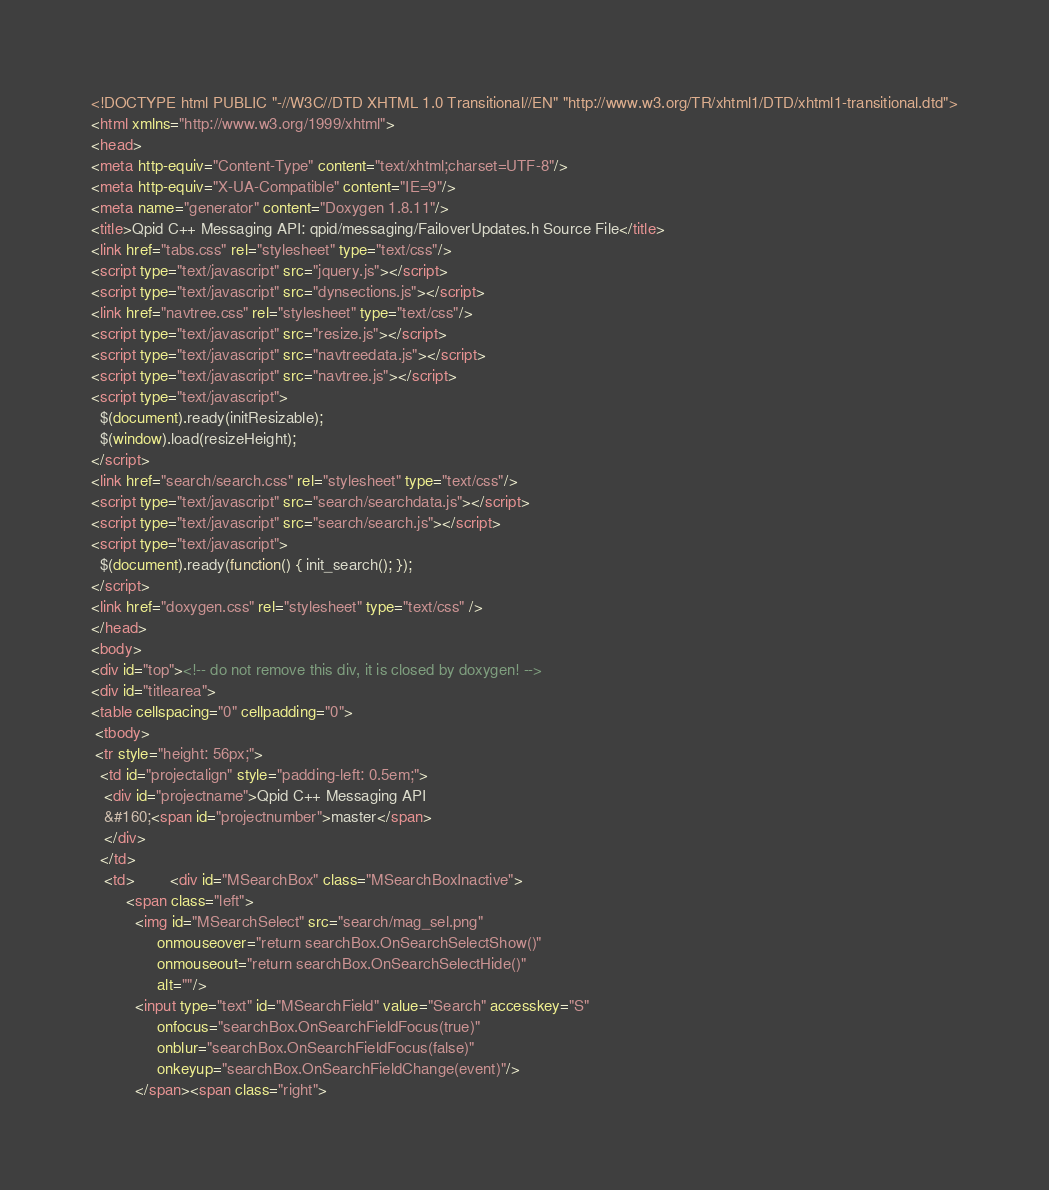Convert code to text. <code><loc_0><loc_0><loc_500><loc_500><_HTML_><!DOCTYPE html PUBLIC "-//W3C//DTD XHTML 1.0 Transitional//EN" "http://www.w3.org/TR/xhtml1/DTD/xhtml1-transitional.dtd">
<html xmlns="http://www.w3.org/1999/xhtml">
<head>
<meta http-equiv="Content-Type" content="text/xhtml;charset=UTF-8"/>
<meta http-equiv="X-UA-Compatible" content="IE=9"/>
<meta name="generator" content="Doxygen 1.8.11"/>
<title>Qpid C++ Messaging API: qpid/messaging/FailoverUpdates.h Source File</title>
<link href="tabs.css" rel="stylesheet" type="text/css"/>
<script type="text/javascript" src="jquery.js"></script>
<script type="text/javascript" src="dynsections.js"></script>
<link href="navtree.css" rel="stylesheet" type="text/css"/>
<script type="text/javascript" src="resize.js"></script>
<script type="text/javascript" src="navtreedata.js"></script>
<script type="text/javascript" src="navtree.js"></script>
<script type="text/javascript">
  $(document).ready(initResizable);
  $(window).load(resizeHeight);
</script>
<link href="search/search.css" rel="stylesheet" type="text/css"/>
<script type="text/javascript" src="search/searchdata.js"></script>
<script type="text/javascript" src="search/search.js"></script>
<script type="text/javascript">
  $(document).ready(function() { init_search(); });
</script>
<link href="doxygen.css" rel="stylesheet" type="text/css" />
</head>
<body>
<div id="top"><!-- do not remove this div, it is closed by doxygen! -->
<div id="titlearea">
<table cellspacing="0" cellpadding="0">
 <tbody>
 <tr style="height: 56px;">
  <td id="projectalign" style="padding-left: 0.5em;">
   <div id="projectname">Qpid C++ Messaging API
   &#160;<span id="projectnumber">master</span>
   </div>
  </td>
   <td>        <div id="MSearchBox" class="MSearchBoxInactive">
        <span class="left">
          <img id="MSearchSelect" src="search/mag_sel.png"
               onmouseover="return searchBox.OnSearchSelectShow()"
               onmouseout="return searchBox.OnSearchSelectHide()"
               alt=""/>
          <input type="text" id="MSearchField" value="Search" accesskey="S"
               onfocus="searchBox.OnSearchFieldFocus(true)" 
               onblur="searchBox.OnSearchFieldFocus(false)" 
               onkeyup="searchBox.OnSearchFieldChange(event)"/>
          </span><span class="right"></code> 